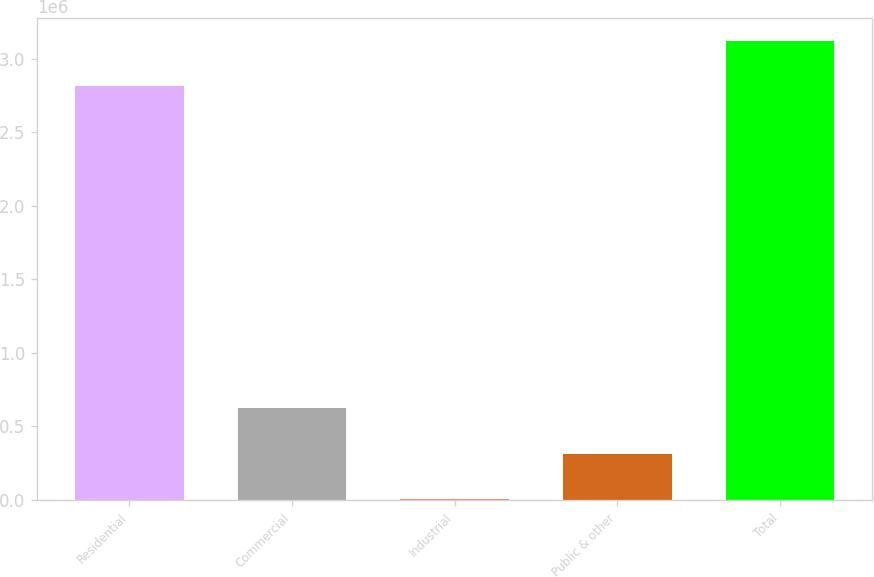Convert chart to OTSL. <chart><loc_0><loc_0><loc_500><loc_500><bar_chart><fcel>Residential<fcel>Commercial<fcel>Industrial<fcel>Public & other<fcel>Total<nl><fcel>2.8136e+06<fcel>622128<fcel>3822<fcel>312975<fcel>3.12275e+06<nl></chart> 